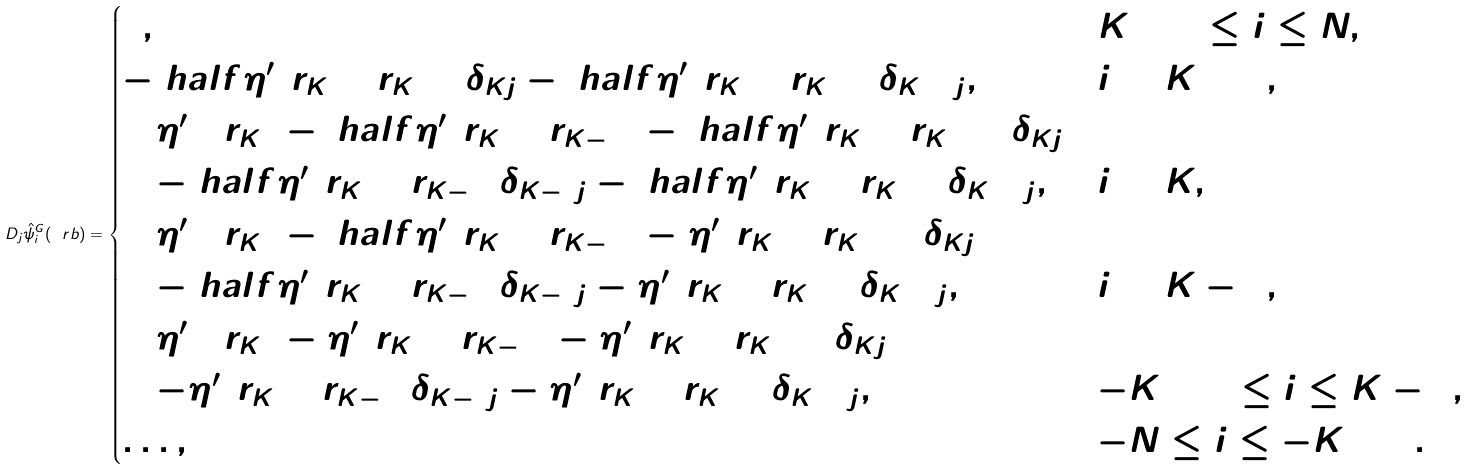Convert formula to latex. <formula><loc_0><loc_0><loc_500><loc_500>D _ { j } \hat { \psi } ^ { G } _ { i } ( \ r b ) = \begin{cases} 0 , & K + 2 \leq i \leq N , \\ - \ h a l f \eta ^ { \prime } ( r _ { K } + r _ { K + 1 } ) \delta _ { K j } - \ h a l f \eta ^ { \prime } ( r _ { K } + r _ { K + 1 } ) \delta _ { K + 1 j } , & i = K + 1 , \\ [ 2 \eta ^ { \prime } ( 2 r _ { K } ) - \ h a l f \eta ^ { \prime } ( r _ { K } + r _ { K - 1 } ) - \ h a l f \eta ^ { \prime } ( r _ { K } + r _ { K + 1 } ) ] \delta _ { K j } & \\ \quad - \ h a l f \eta ^ { \prime } ( r _ { K } + r _ { K - 1 } ) \delta _ { K - 1 j } - \ h a l f \eta ^ { \prime } ( r _ { K } + r _ { K + 1 } ) \delta _ { K + 1 j } , & i = K , \\ [ 4 \eta ^ { \prime } ( 2 r _ { K } ) - \ h a l f \eta ^ { \prime } ( r _ { K } + r _ { K - 1 } ) - \eta ^ { \prime } ( r _ { K } + r _ { K + 1 } ) ] \delta _ { K j } & \\ \quad - \ h a l f \eta ^ { \prime } ( r _ { K } + r _ { K - 1 } ) \delta _ { K - 1 j } - \eta ^ { \prime } ( r _ { K } + r _ { K + 1 } ) \delta _ { K + 1 j } , & i = K - 1 , \\ [ 4 \eta ^ { \prime } ( 2 r _ { K } ) - \eta ^ { \prime } ( r _ { K } + r _ { K - 1 } ) - \eta ^ { \prime } ( r _ { K } + r _ { K + 1 } ) ] \delta _ { K j } & \\ \quad - \eta ^ { \prime } ( r _ { K } + r _ { K - 1 } ) \delta _ { K - 1 j } - \eta ^ { \prime } ( r _ { K } + r _ { K + 1 } ) \delta _ { K + 1 j } , & - K + 2 \leq i \leq K - 2 , \\ \dots , & - N \leq i \leq - K + 3 . \end{cases}</formula> 